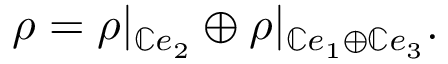Convert formula to latex. <formula><loc_0><loc_0><loc_500><loc_500>\rho = \rho | _ { \mathbb { C } e _ { 2 } } \oplus \rho | _ { \mathbb { C } e _ { 1 } \oplus \mathbb { C } e _ { 3 } } .</formula> 